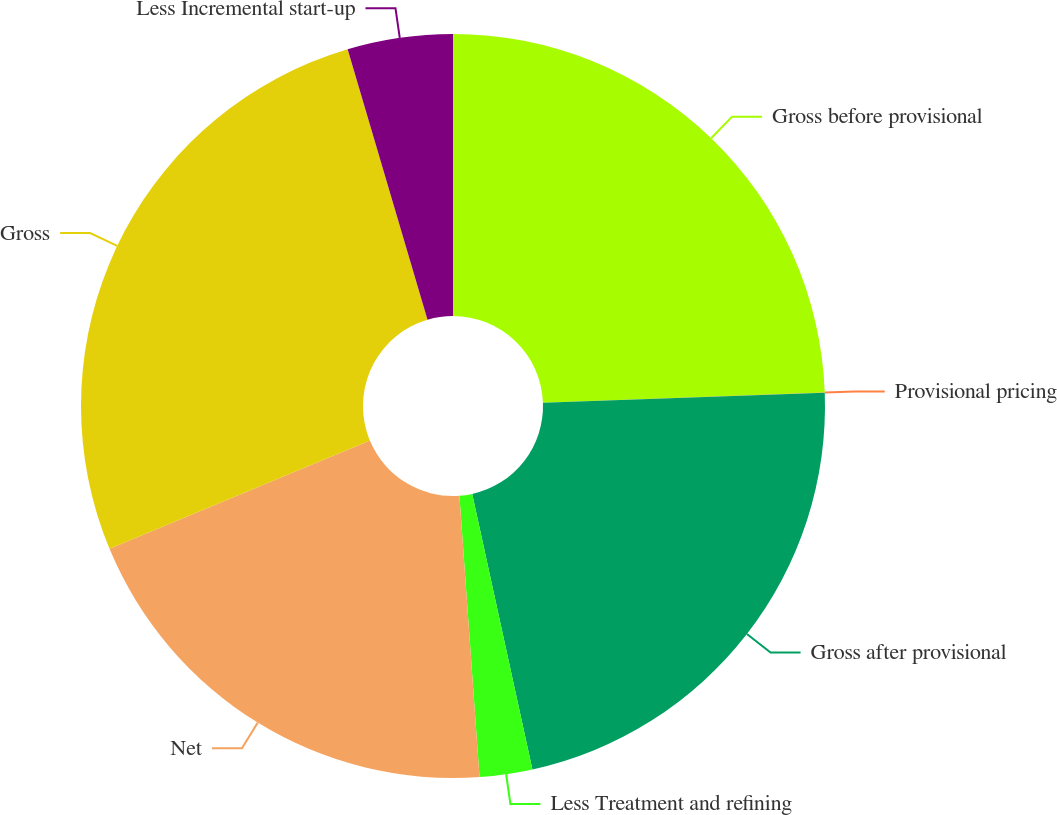<chart> <loc_0><loc_0><loc_500><loc_500><pie_chart><fcel>Gross before provisional<fcel>Provisional pricing<fcel>Gross after provisional<fcel>Less Treatment and refining<fcel>Net<fcel>Gross<fcel>Less Incremental start-up<nl><fcel>24.42%<fcel>0.01%<fcel>22.14%<fcel>2.29%<fcel>19.86%<fcel>26.7%<fcel>4.57%<nl></chart> 